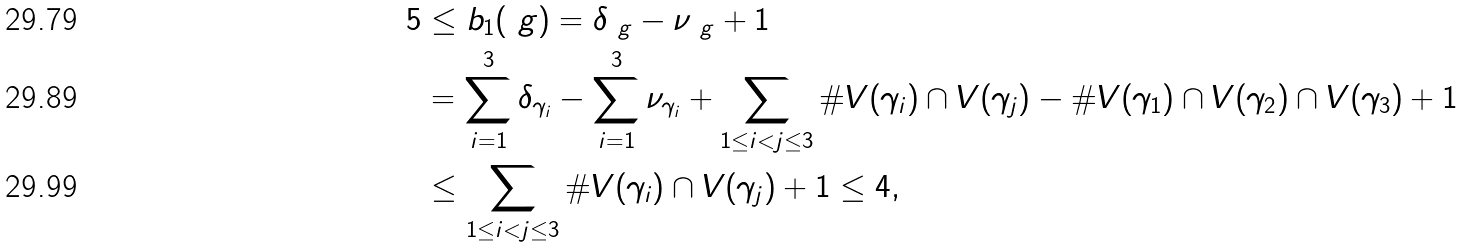Convert formula to latex. <formula><loc_0><loc_0><loc_500><loc_500>5 & \leq b _ { 1 } ( \ g ) = \delta _ { \ g } - \nu _ { \ g } + 1 \\ & = \sum _ { i = 1 } ^ { 3 } \delta _ { \gamma _ { i } } - \sum _ { i = 1 } ^ { 3 } \nu _ { \gamma _ { i } } + \sum _ { 1 \leq i < j \leq 3 } \# V ( \gamma _ { i } ) \cap V ( \gamma _ { j } ) - \# V ( \gamma _ { 1 } ) \cap V ( \gamma _ { 2 } ) \cap V ( \gamma _ { 3 } ) + 1 \\ & \leq \sum _ { 1 \leq i < j \leq 3 } \# V ( \gamma _ { i } ) \cap V ( \gamma _ { j } ) + 1 \leq 4 ,</formula> 